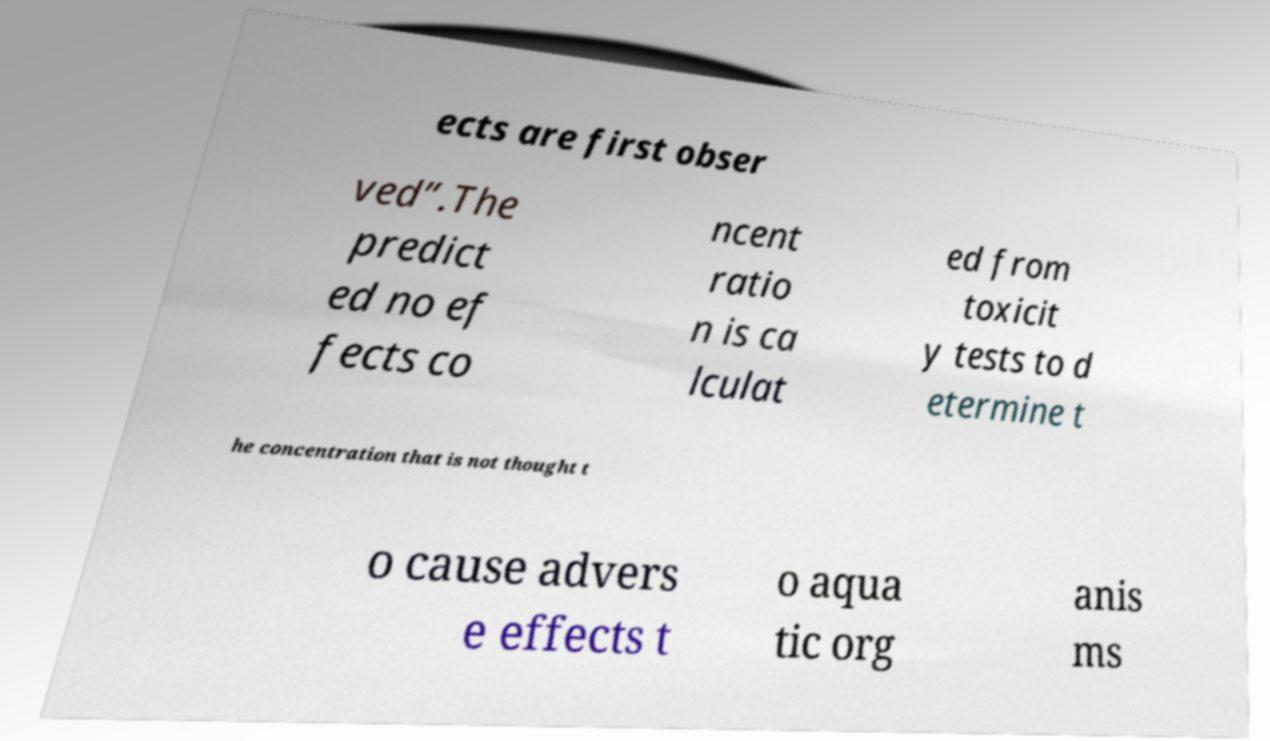Please identify and transcribe the text found in this image. ects are first obser ved”.The predict ed no ef fects co ncent ratio n is ca lculat ed from toxicit y tests to d etermine t he concentration that is not thought t o cause advers e effects t o aqua tic org anis ms 